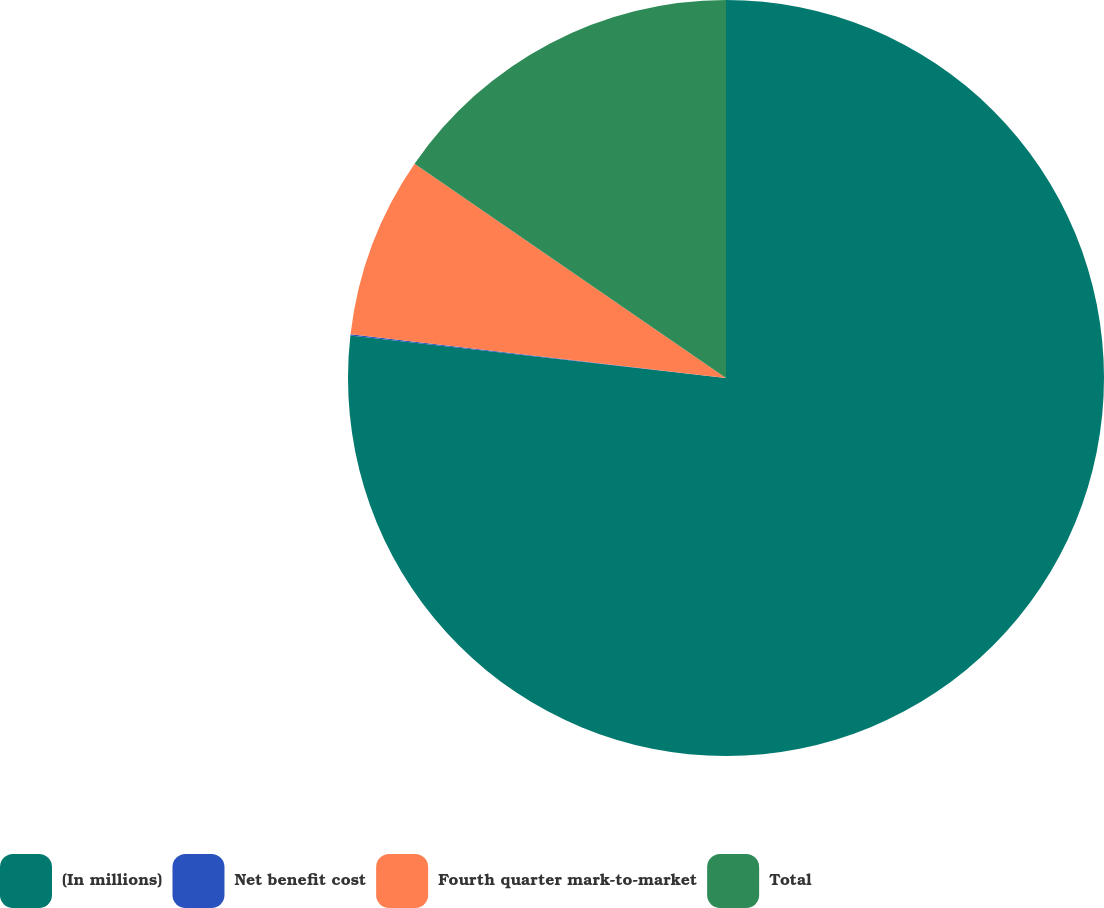Convert chart to OTSL. <chart><loc_0><loc_0><loc_500><loc_500><pie_chart><fcel>(In millions)<fcel>Net benefit cost<fcel>Fourth quarter mark-to-market<fcel>Total<nl><fcel>76.79%<fcel>0.06%<fcel>7.74%<fcel>15.41%<nl></chart> 